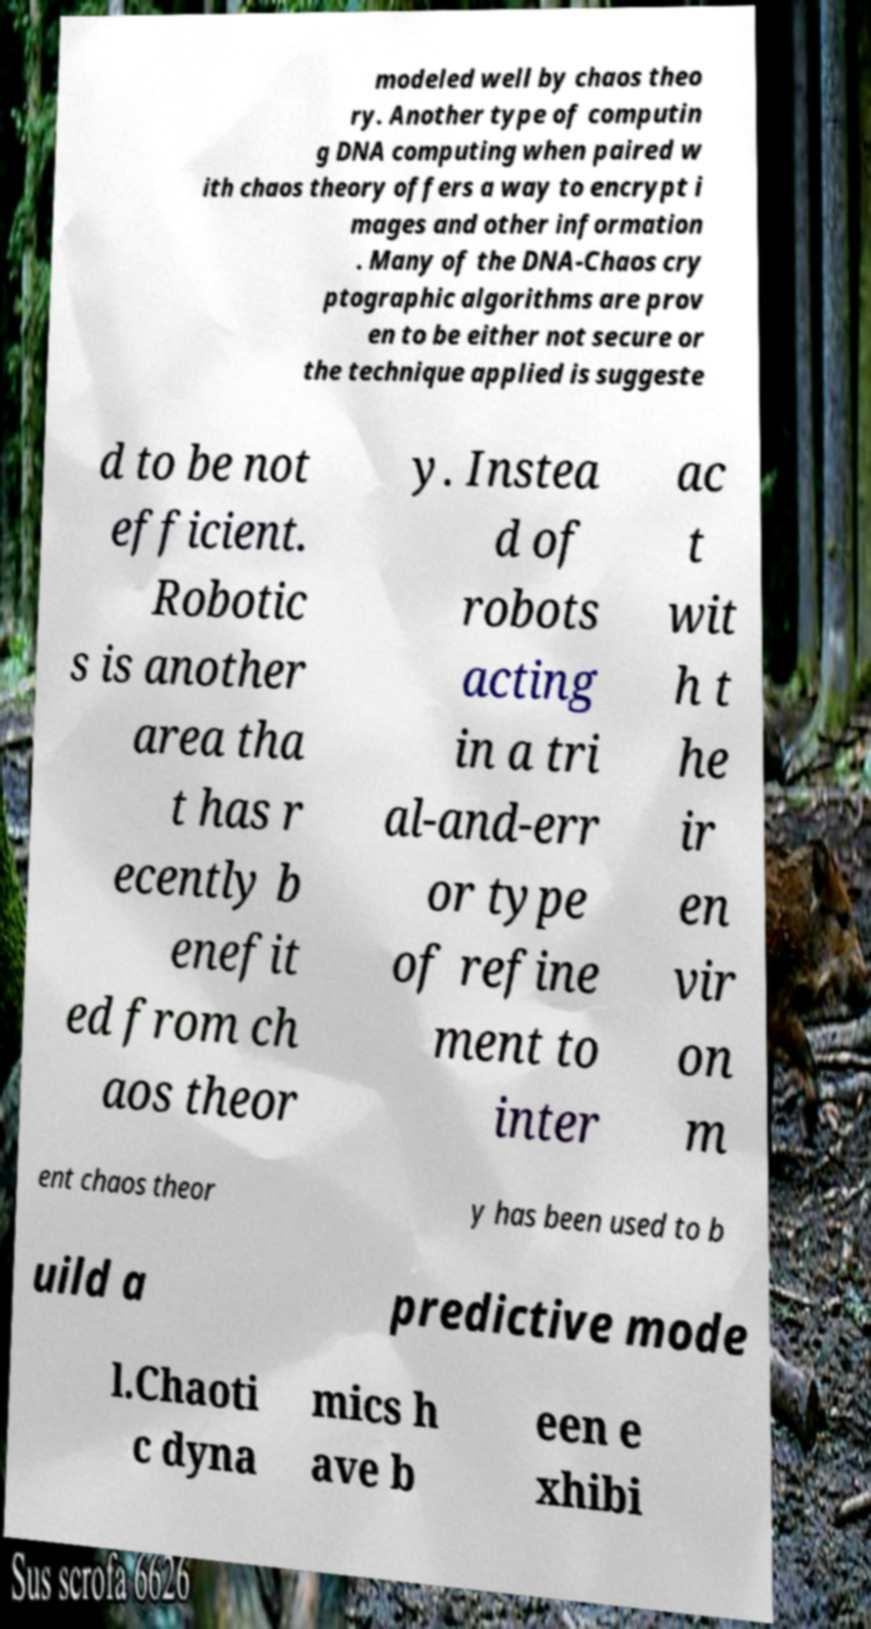Please identify and transcribe the text found in this image. modeled well by chaos theo ry. Another type of computin g DNA computing when paired w ith chaos theory offers a way to encrypt i mages and other information . Many of the DNA-Chaos cry ptographic algorithms are prov en to be either not secure or the technique applied is suggeste d to be not efficient. Robotic s is another area tha t has r ecently b enefit ed from ch aos theor y. Instea d of robots acting in a tri al-and-err or type of refine ment to inter ac t wit h t he ir en vir on m ent chaos theor y has been used to b uild a predictive mode l.Chaoti c dyna mics h ave b een e xhibi 